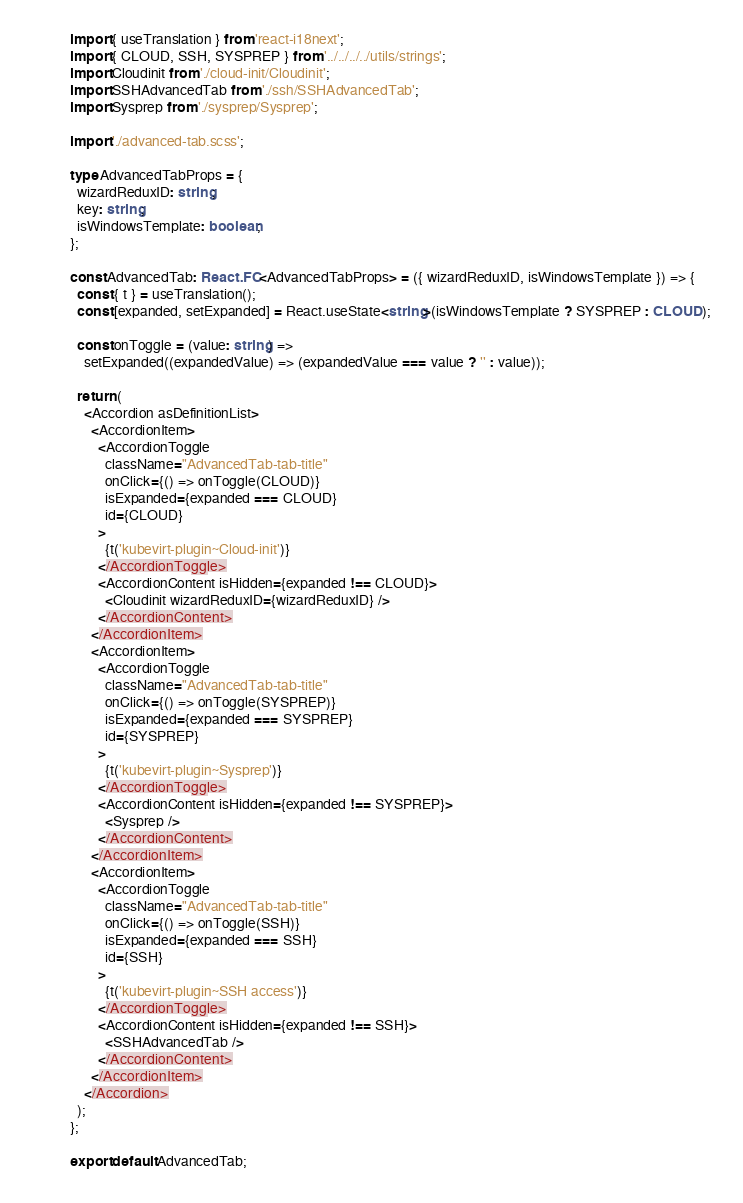Convert code to text. <code><loc_0><loc_0><loc_500><loc_500><_TypeScript_>import { useTranslation } from 'react-i18next';
import { CLOUD, SSH, SYSPREP } from '../../../../utils/strings';
import Cloudinit from './cloud-init/Cloudinit';
import SSHAdvancedTab from './ssh/SSHAdvancedTab';
import Sysprep from './sysprep/Sysprep';

import './advanced-tab.scss';

type AdvancedTabProps = {
  wizardReduxID: string;
  key: string;
  isWindowsTemplate: boolean;
};

const AdvancedTab: React.FC<AdvancedTabProps> = ({ wizardReduxID, isWindowsTemplate }) => {
  const { t } = useTranslation();
  const [expanded, setExpanded] = React.useState<string>(isWindowsTemplate ? SYSPREP : CLOUD);

  const onToggle = (value: string) =>
    setExpanded((expandedValue) => (expandedValue === value ? '' : value));

  return (
    <Accordion asDefinitionList>
      <AccordionItem>
        <AccordionToggle
          className="AdvancedTab-tab-title"
          onClick={() => onToggle(CLOUD)}
          isExpanded={expanded === CLOUD}
          id={CLOUD}
        >
          {t('kubevirt-plugin~Cloud-init')}
        </AccordionToggle>
        <AccordionContent isHidden={expanded !== CLOUD}>
          <Cloudinit wizardReduxID={wizardReduxID} />
        </AccordionContent>
      </AccordionItem>
      <AccordionItem>
        <AccordionToggle
          className="AdvancedTab-tab-title"
          onClick={() => onToggle(SYSPREP)}
          isExpanded={expanded === SYSPREP}
          id={SYSPREP}
        >
          {t('kubevirt-plugin~Sysprep')}
        </AccordionToggle>
        <AccordionContent isHidden={expanded !== SYSPREP}>
          <Sysprep />
        </AccordionContent>
      </AccordionItem>
      <AccordionItem>
        <AccordionToggle
          className="AdvancedTab-tab-title"
          onClick={() => onToggle(SSH)}
          isExpanded={expanded === SSH}
          id={SSH}
        >
          {t('kubevirt-plugin~SSH access')}
        </AccordionToggle>
        <AccordionContent isHidden={expanded !== SSH}>
          <SSHAdvancedTab />
        </AccordionContent>
      </AccordionItem>
    </Accordion>
  );
};

export default AdvancedTab;
</code> 